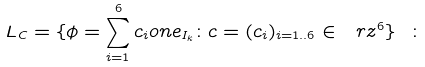Convert formula to latex. <formula><loc_0><loc_0><loc_500><loc_500>L _ { C } = \{ \phi = \sum _ { i = 1 } ^ { 6 } c _ { i } o n e _ { I _ { k } } \colon c = ( c _ { i } ) _ { i = 1 . . 6 } \in \ r z ^ { 6 } \} \ \colon</formula> 